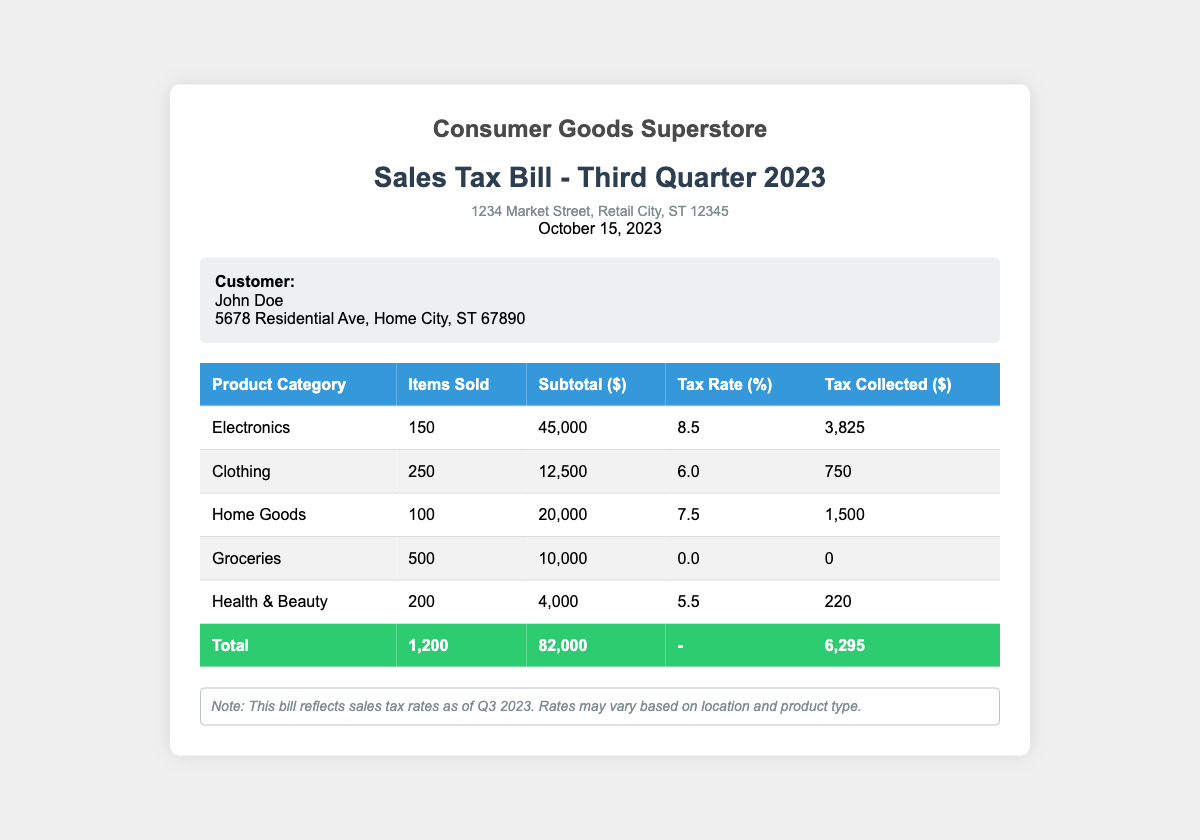What is the total tax collected? The total tax collected is found in the total row of the table, which shows a total of $6,295.
Answer: $6,295 What is the tax rate for Electronics? The tax rate for Electronics is specified in the corresponding row of the table, which shows 8.5%.
Answer: 8.5% How many items were sold in the Clothing category? The number of items sold in the Clothing category is listed as 250 in the table.
Answer: 250 What is the subtotal for Home Goods? The subtotal for Home Goods is found in the table and is $20,000.
Answer: $20,000 Which product category has the lowest tax collected? The product category with the lowest tax collected can be found in the table that lists Health & Beauty with $220.
Answer: Health & Beauty What is the total number of items sold across all categories? The total number of items sold is given in the total row of the table and is 1,200.
Answer: 1,200 What is the date of the bill? The date of the bill can be found in the header section, listed as October 15, 2023.
Answer: October 15, 2023 What is the address of the store? The address of the store is provided in the header section, stating 1234 Market Street, Retail City, ST 12345.
Answer: 1234 Market Street, Retail City, ST 12345 What percentage tax is applied to Groceries? The percentage tax applied to Groceries is noted in the table and is 0.0%.
Answer: 0.0% 